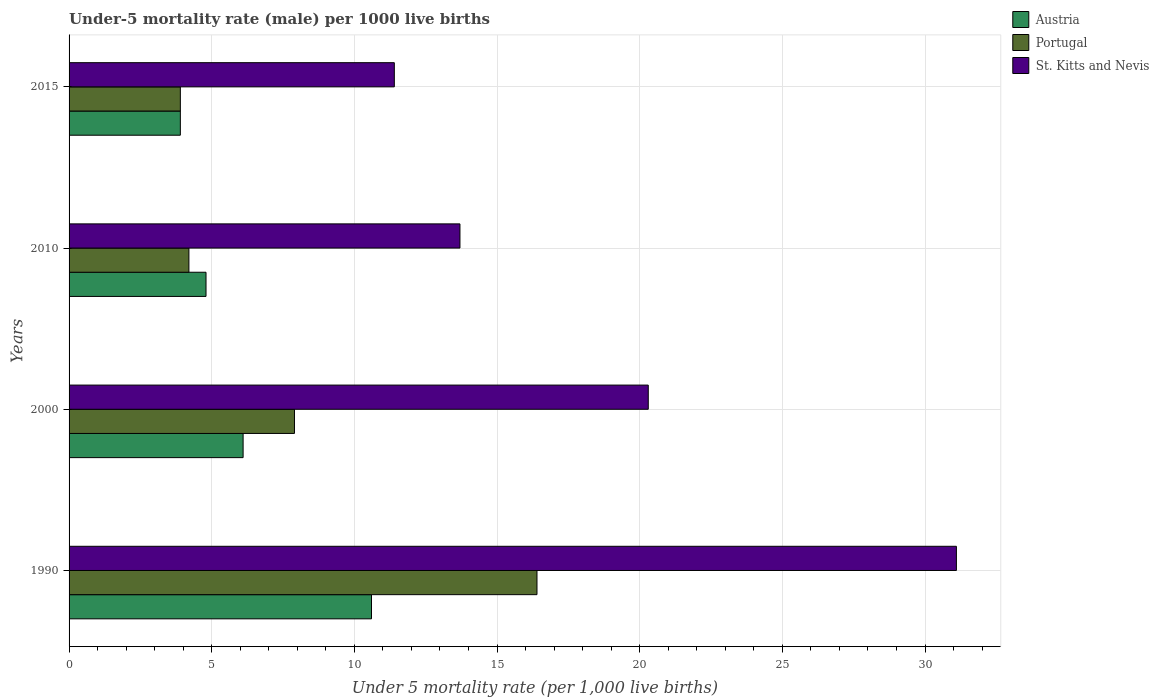Are the number of bars on each tick of the Y-axis equal?
Your response must be concise. Yes. How many bars are there on the 4th tick from the top?
Keep it short and to the point. 3. How many bars are there on the 3rd tick from the bottom?
Ensure brevity in your answer.  3. In how many cases, is the number of bars for a given year not equal to the number of legend labels?
Give a very brief answer. 0. What is the under-five mortality rate in Austria in 2010?
Give a very brief answer. 4.8. In which year was the under-five mortality rate in St. Kitts and Nevis minimum?
Offer a terse response. 2015. What is the total under-five mortality rate in Austria in the graph?
Ensure brevity in your answer.  25.4. What is the difference between the under-five mortality rate in St. Kitts and Nevis in 1990 and that in 2010?
Your answer should be very brief. 17.4. What is the difference between the under-five mortality rate in St. Kitts and Nevis in 2000 and the under-five mortality rate in Austria in 2015?
Provide a short and direct response. 16.4. What is the average under-five mortality rate in Austria per year?
Make the answer very short. 6.35. In the year 2000, what is the difference between the under-five mortality rate in Portugal and under-five mortality rate in Austria?
Your answer should be very brief. 1.8. In how many years, is the under-five mortality rate in St. Kitts and Nevis greater than 21 ?
Offer a very short reply. 1. What is the ratio of the under-five mortality rate in Portugal in 1990 to that in 2010?
Provide a succinct answer. 3.9. What is the difference between the highest and the lowest under-five mortality rate in St. Kitts and Nevis?
Offer a very short reply. 19.7. In how many years, is the under-five mortality rate in St. Kitts and Nevis greater than the average under-five mortality rate in St. Kitts and Nevis taken over all years?
Offer a terse response. 2. Is the sum of the under-five mortality rate in Portugal in 2010 and 2015 greater than the maximum under-five mortality rate in St. Kitts and Nevis across all years?
Keep it short and to the point. No. What does the 1st bar from the top in 2000 represents?
Provide a short and direct response. St. Kitts and Nevis. How many years are there in the graph?
Your response must be concise. 4. Are the values on the major ticks of X-axis written in scientific E-notation?
Your answer should be compact. No. Does the graph contain any zero values?
Your response must be concise. No. Does the graph contain grids?
Give a very brief answer. Yes. Where does the legend appear in the graph?
Your answer should be compact. Top right. How are the legend labels stacked?
Your response must be concise. Vertical. What is the title of the graph?
Provide a succinct answer. Under-5 mortality rate (male) per 1000 live births. Does "Bermuda" appear as one of the legend labels in the graph?
Keep it short and to the point. No. What is the label or title of the X-axis?
Keep it short and to the point. Under 5 mortality rate (per 1,0 live births). What is the label or title of the Y-axis?
Provide a short and direct response. Years. What is the Under 5 mortality rate (per 1,000 live births) in Austria in 1990?
Ensure brevity in your answer.  10.6. What is the Under 5 mortality rate (per 1,000 live births) of St. Kitts and Nevis in 1990?
Keep it short and to the point. 31.1. What is the Under 5 mortality rate (per 1,000 live births) of Portugal in 2000?
Your answer should be compact. 7.9. What is the Under 5 mortality rate (per 1,000 live births) in St. Kitts and Nevis in 2000?
Offer a very short reply. 20.3. What is the Under 5 mortality rate (per 1,000 live births) of Portugal in 2010?
Offer a very short reply. 4.2. What is the Under 5 mortality rate (per 1,000 live births) in St. Kitts and Nevis in 2010?
Provide a succinct answer. 13.7. What is the Under 5 mortality rate (per 1,000 live births) of Portugal in 2015?
Make the answer very short. 3.9. What is the Under 5 mortality rate (per 1,000 live births) in St. Kitts and Nevis in 2015?
Offer a very short reply. 11.4. Across all years, what is the maximum Under 5 mortality rate (per 1,000 live births) in St. Kitts and Nevis?
Ensure brevity in your answer.  31.1. Across all years, what is the minimum Under 5 mortality rate (per 1,000 live births) in Austria?
Provide a succinct answer. 3.9. Across all years, what is the minimum Under 5 mortality rate (per 1,000 live births) of Portugal?
Offer a very short reply. 3.9. Across all years, what is the minimum Under 5 mortality rate (per 1,000 live births) of St. Kitts and Nevis?
Give a very brief answer. 11.4. What is the total Under 5 mortality rate (per 1,000 live births) in Austria in the graph?
Your answer should be compact. 25.4. What is the total Under 5 mortality rate (per 1,000 live births) in Portugal in the graph?
Your response must be concise. 32.4. What is the total Under 5 mortality rate (per 1,000 live births) of St. Kitts and Nevis in the graph?
Make the answer very short. 76.5. What is the difference between the Under 5 mortality rate (per 1,000 live births) of Austria in 1990 and that in 2000?
Give a very brief answer. 4.5. What is the difference between the Under 5 mortality rate (per 1,000 live births) in Austria in 1990 and that in 2010?
Offer a terse response. 5.8. What is the difference between the Under 5 mortality rate (per 1,000 live births) of Portugal in 1990 and that in 2015?
Make the answer very short. 12.5. What is the difference between the Under 5 mortality rate (per 1,000 live births) in St. Kitts and Nevis in 1990 and that in 2015?
Offer a terse response. 19.7. What is the difference between the Under 5 mortality rate (per 1,000 live births) in Austria in 2000 and that in 2010?
Offer a very short reply. 1.3. What is the difference between the Under 5 mortality rate (per 1,000 live births) of Austria in 2000 and that in 2015?
Provide a succinct answer. 2.2. What is the difference between the Under 5 mortality rate (per 1,000 live births) of Portugal in 2000 and that in 2015?
Offer a very short reply. 4. What is the difference between the Under 5 mortality rate (per 1,000 live births) of St. Kitts and Nevis in 2010 and that in 2015?
Your response must be concise. 2.3. What is the difference between the Under 5 mortality rate (per 1,000 live births) in Austria in 1990 and the Under 5 mortality rate (per 1,000 live births) in Portugal in 2000?
Give a very brief answer. 2.7. What is the difference between the Under 5 mortality rate (per 1,000 live births) of Austria in 1990 and the Under 5 mortality rate (per 1,000 live births) of St. Kitts and Nevis in 2010?
Your answer should be compact. -3.1. What is the difference between the Under 5 mortality rate (per 1,000 live births) of Austria in 1990 and the Under 5 mortality rate (per 1,000 live births) of Portugal in 2015?
Provide a short and direct response. 6.7. What is the difference between the Under 5 mortality rate (per 1,000 live births) of Austria in 2000 and the Under 5 mortality rate (per 1,000 live births) of Portugal in 2010?
Give a very brief answer. 1.9. What is the difference between the Under 5 mortality rate (per 1,000 live births) of Portugal in 2000 and the Under 5 mortality rate (per 1,000 live births) of St. Kitts and Nevis in 2010?
Keep it short and to the point. -5.8. What is the difference between the Under 5 mortality rate (per 1,000 live births) in Austria in 2000 and the Under 5 mortality rate (per 1,000 live births) in Portugal in 2015?
Your answer should be very brief. 2.2. What is the difference between the Under 5 mortality rate (per 1,000 live births) of Portugal in 2010 and the Under 5 mortality rate (per 1,000 live births) of St. Kitts and Nevis in 2015?
Ensure brevity in your answer.  -7.2. What is the average Under 5 mortality rate (per 1,000 live births) of Austria per year?
Keep it short and to the point. 6.35. What is the average Under 5 mortality rate (per 1,000 live births) of St. Kitts and Nevis per year?
Keep it short and to the point. 19.12. In the year 1990, what is the difference between the Under 5 mortality rate (per 1,000 live births) in Austria and Under 5 mortality rate (per 1,000 live births) in St. Kitts and Nevis?
Keep it short and to the point. -20.5. In the year 1990, what is the difference between the Under 5 mortality rate (per 1,000 live births) of Portugal and Under 5 mortality rate (per 1,000 live births) of St. Kitts and Nevis?
Your answer should be compact. -14.7. In the year 2000, what is the difference between the Under 5 mortality rate (per 1,000 live births) in Austria and Under 5 mortality rate (per 1,000 live births) in Portugal?
Your answer should be compact. -1.8. In the year 2010, what is the difference between the Under 5 mortality rate (per 1,000 live births) of Austria and Under 5 mortality rate (per 1,000 live births) of St. Kitts and Nevis?
Keep it short and to the point. -8.9. In the year 2015, what is the difference between the Under 5 mortality rate (per 1,000 live births) in Austria and Under 5 mortality rate (per 1,000 live births) in St. Kitts and Nevis?
Your response must be concise. -7.5. In the year 2015, what is the difference between the Under 5 mortality rate (per 1,000 live births) of Portugal and Under 5 mortality rate (per 1,000 live births) of St. Kitts and Nevis?
Your answer should be compact. -7.5. What is the ratio of the Under 5 mortality rate (per 1,000 live births) in Austria in 1990 to that in 2000?
Provide a succinct answer. 1.74. What is the ratio of the Under 5 mortality rate (per 1,000 live births) in Portugal in 1990 to that in 2000?
Your response must be concise. 2.08. What is the ratio of the Under 5 mortality rate (per 1,000 live births) of St. Kitts and Nevis in 1990 to that in 2000?
Provide a succinct answer. 1.53. What is the ratio of the Under 5 mortality rate (per 1,000 live births) in Austria in 1990 to that in 2010?
Provide a short and direct response. 2.21. What is the ratio of the Under 5 mortality rate (per 1,000 live births) of Portugal in 1990 to that in 2010?
Offer a terse response. 3.9. What is the ratio of the Under 5 mortality rate (per 1,000 live births) in St. Kitts and Nevis in 1990 to that in 2010?
Offer a terse response. 2.27. What is the ratio of the Under 5 mortality rate (per 1,000 live births) in Austria in 1990 to that in 2015?
Your answer should be compact. 2.72. What is the ratio of the Under 5 mortality rate (per 1,000 live births) of Portugal in 1990 to that in 2015?
Offer a terse response. 4.21. What is the ratio of the Under 5 mortality rate (per 1,000 live births) of St. Kitts and Nevis in 1990 to that in 2015?
Your response must be concise. 2.73. What is the ratio of the Under 5 mortality rate (per 1,000 live births) in Austria in 2000 to that in 2010?
Offer a very short reply. 1.27. What is the ratio of the Under 5 mortality rate (per 1,000 live births) of Portugal in 2000 to that in 2010?
Make the answer very short. 1.88. What is the ratio of the Under 5 mortality rate (per 1,000 live births) of St. Kitts and Nevis in 2000 to that in 2010?
Your answer should be very brief. 1.48. What is the ratio of the Under 5 mortality rate (per 1,000 live births) of Austria in 2000 to that in 2015?
Offer a very short reply. 1.56. What is the ratio of the Under 5 mortality rate (per 1,000 live births) of Portugal in 2000 to that in 2015?
Give a very brief answer. 2.03. What is the ratio of the Under 5 mortality rate (per 1,000 live births) in St. Kitts and Nevis in 2000 to that in 2015?
Make the answer very short. 1.78. What is the ratio of the Under 5 mortality rate (per 1,000 live births) in Austria in 2010 to that in 2015?
Give a very brief answer. 1.23. What is the ratio of the Under 5 mortality rate (per 1,000 live births) in St. Kitts and Nevis in 2010 to that in 2015?
Offer a terse response. 1.2. What is the difference between the highest and the lowest Under 5 mortality rate (per 1,000 live births) in Portugal?
Offer a very short reply. 12.5. 